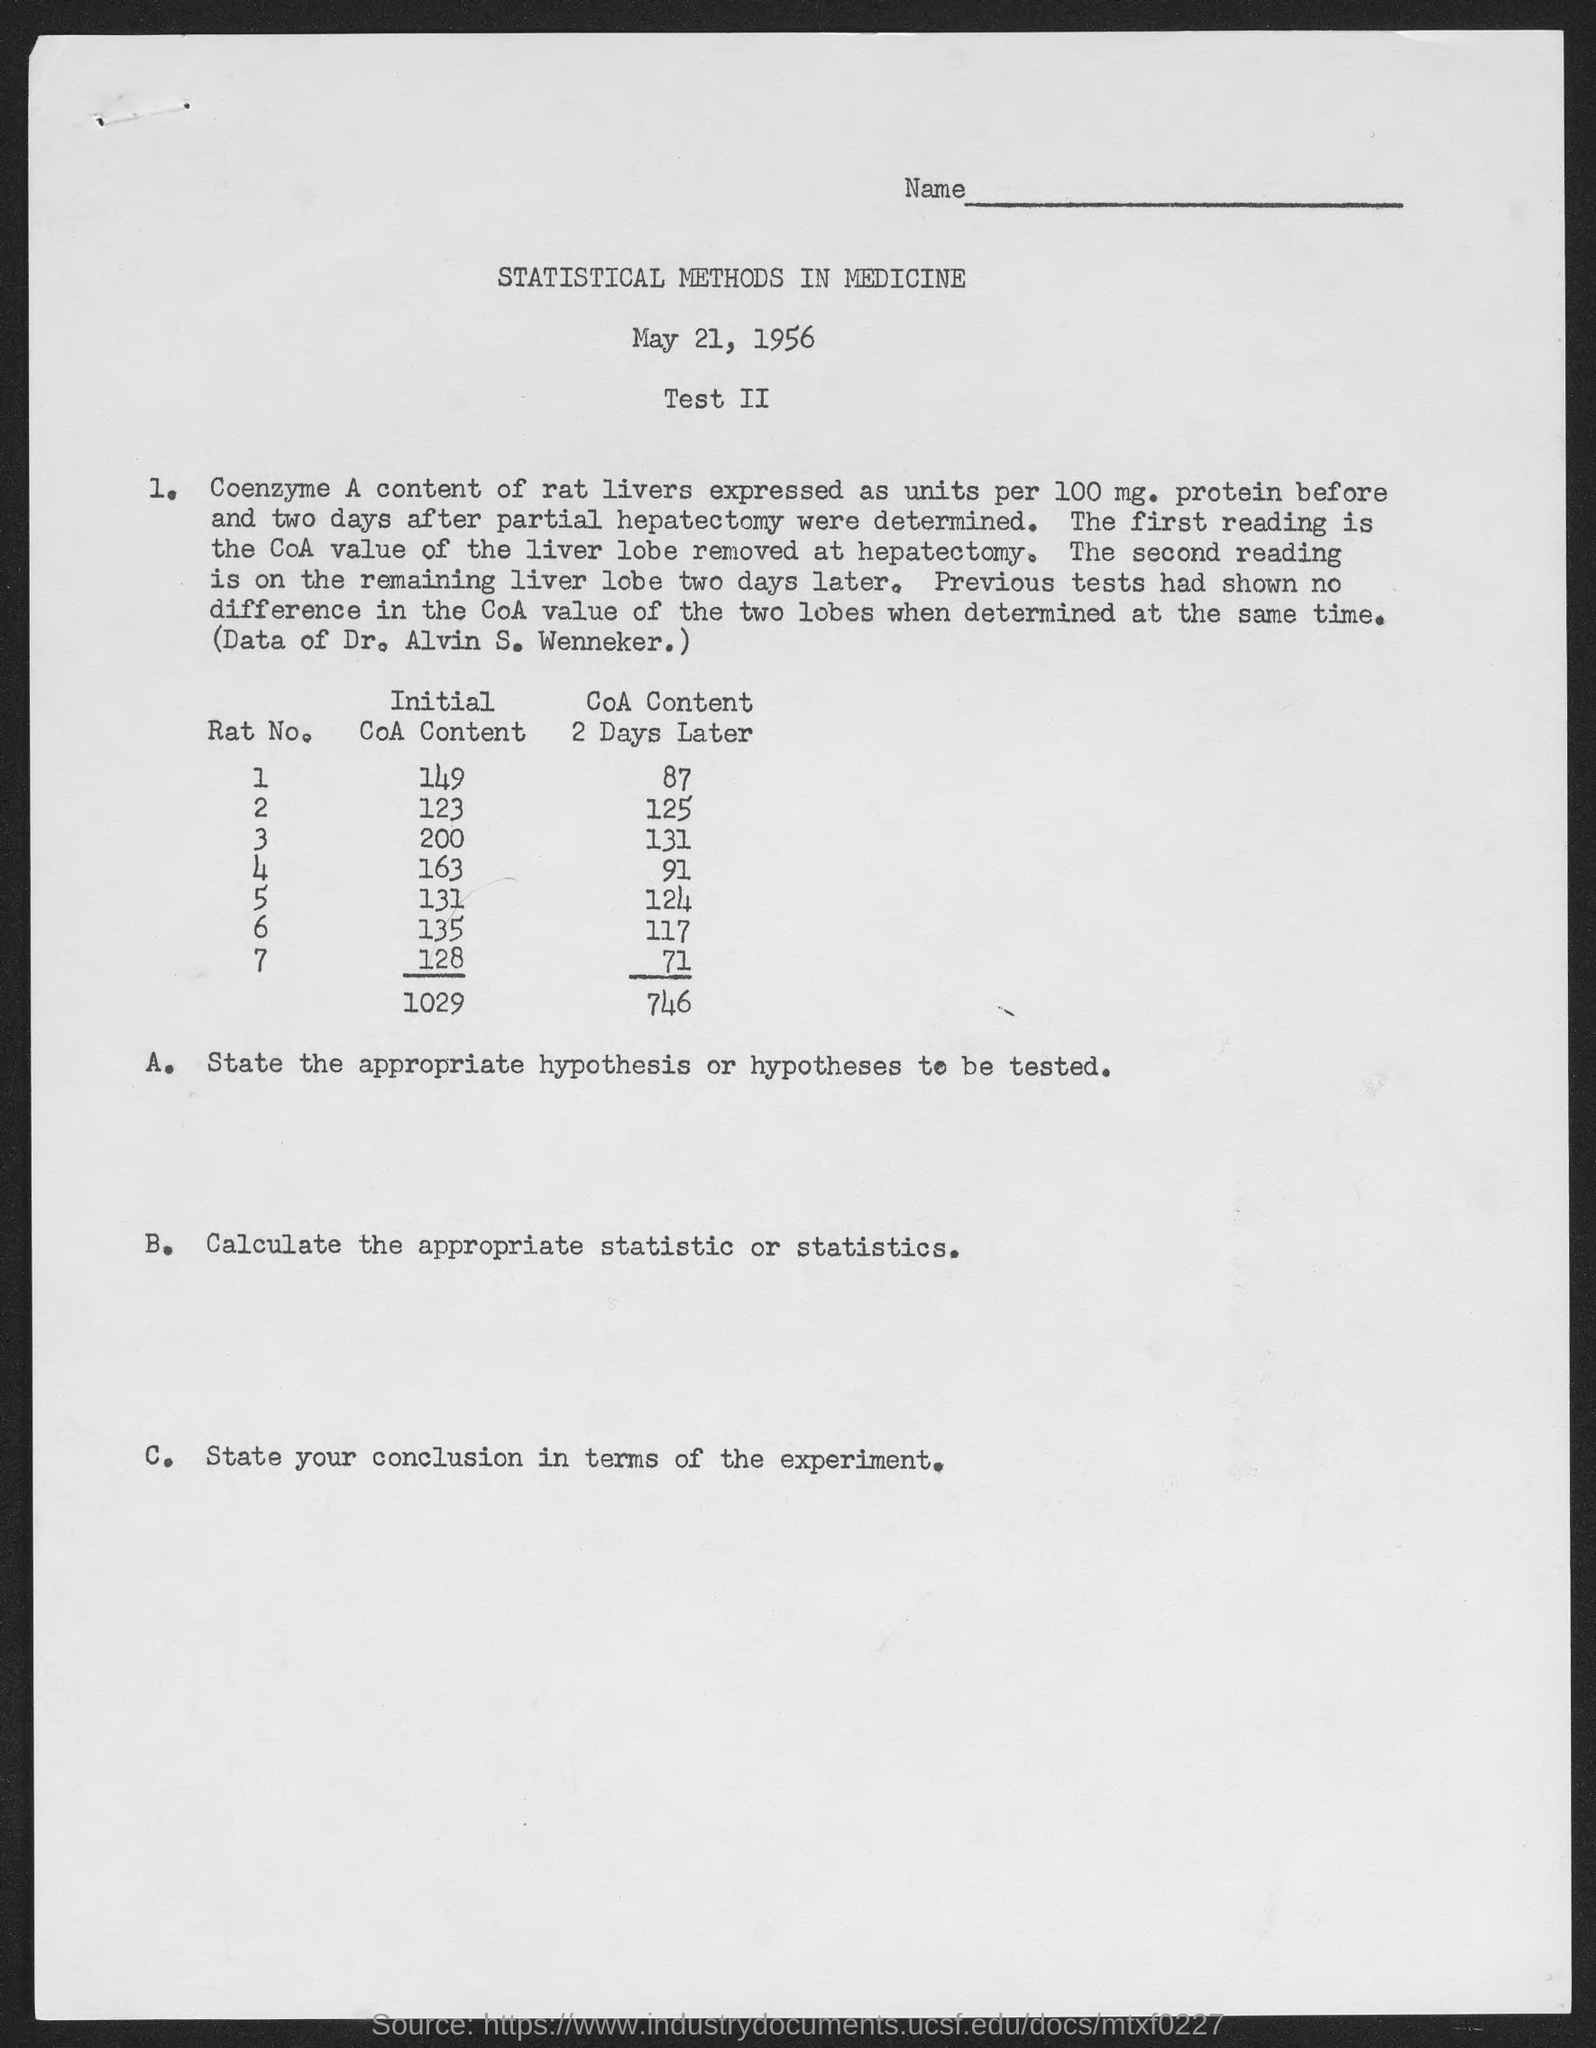Identify some key points in this picture. The initial content of cytosolic acetyl-CoA in rat number 1 is 149... The initial content of Cellular Organelle (CoA) in Rat No. 2 is 123... The initial content of cytosolic acetyl-CoA in Rat no.7 is 128. The initial content of the acetyl-CoA in Rat No. 3 is approximately 200... The CoA content in Rat no. 2 2 days later was found to be 125.. 